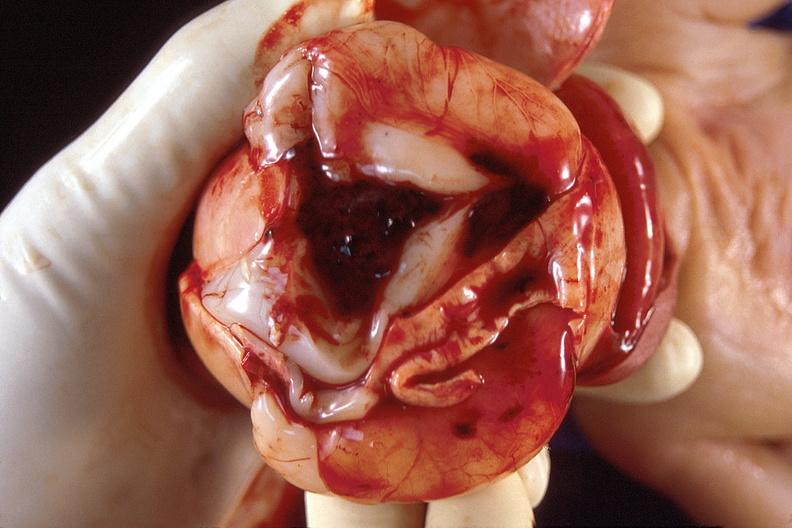s nervous present?
Answer the question using a single word or phrase. Yes 